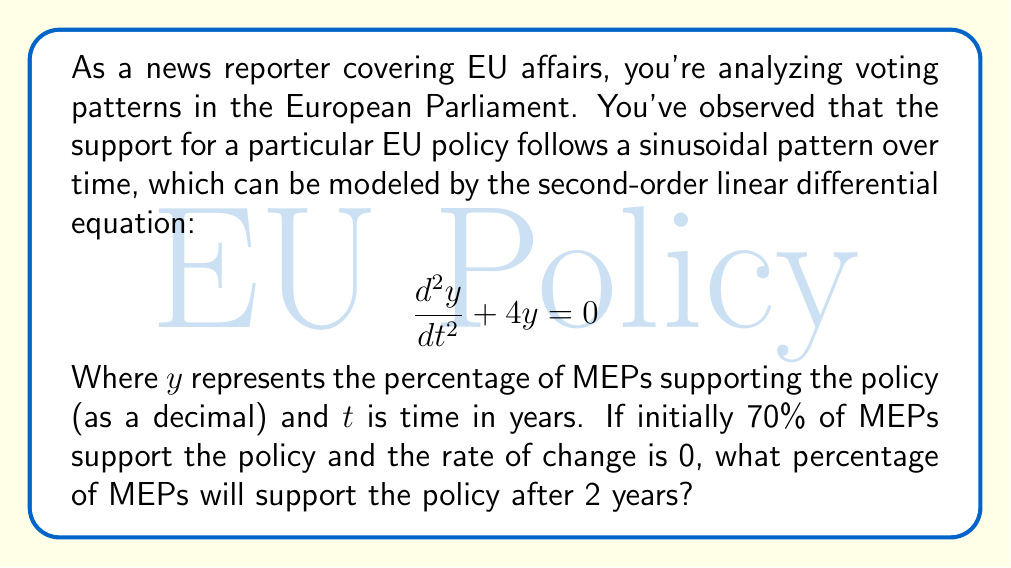Can you answer this question? To solve this problem, we need to follow these steps:

1) The general solution to the given differential equation $\frac{d^2y}{dt^2} + 4y = 0$ is:

   $$y(t) = A\cos(2t) + B\sin(2t)$$

   where $A$ and $B$ are constants determined by initial conditions.

2) We're given two initial conditions:
   - At $t=0$, $y(0) = 0.7$ (70% support)
   - At $t=0$, $\frac{dy}{dt}(0) = 0$ (rate of change is 0)

3) Using the first condition:
   $$y(0) = A\cos(0) + B\sin(0) = A = 0.7$$

4) For the second condition, we differentiate $y(t)$:
   $$\frac{dy}{dt} = -2A\sin(2t) + 2B\cos(2t)$$
   
   At $t=0$:
   $$\frac{dy}{dt}(0) = 2B = 0$$
   $$B = 0$$

5) Therefore, our particular solution is:
   $$y(t) = 0.7\cos(2t)$$

6) To find the percentage after 2 years, we calculate $y(2)$:
   $$y(2) = 0.7\cos(4) \approx 0.6930 \text{ or } 69.30\%$$
Answer: After 2 years, approximately 69.30% of MEPs will support the policy. 